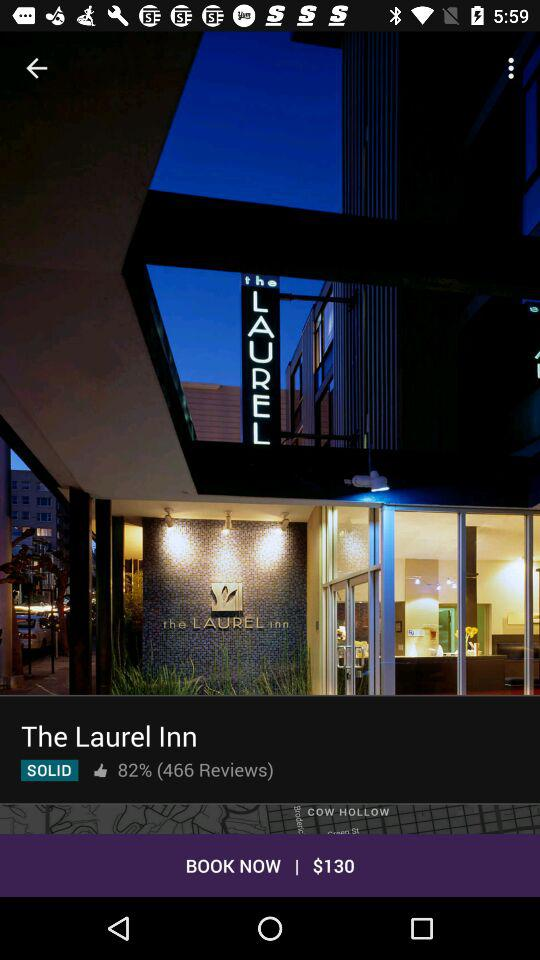What is the name of the hotel? The name of the hotel is The Laurel Inn. 